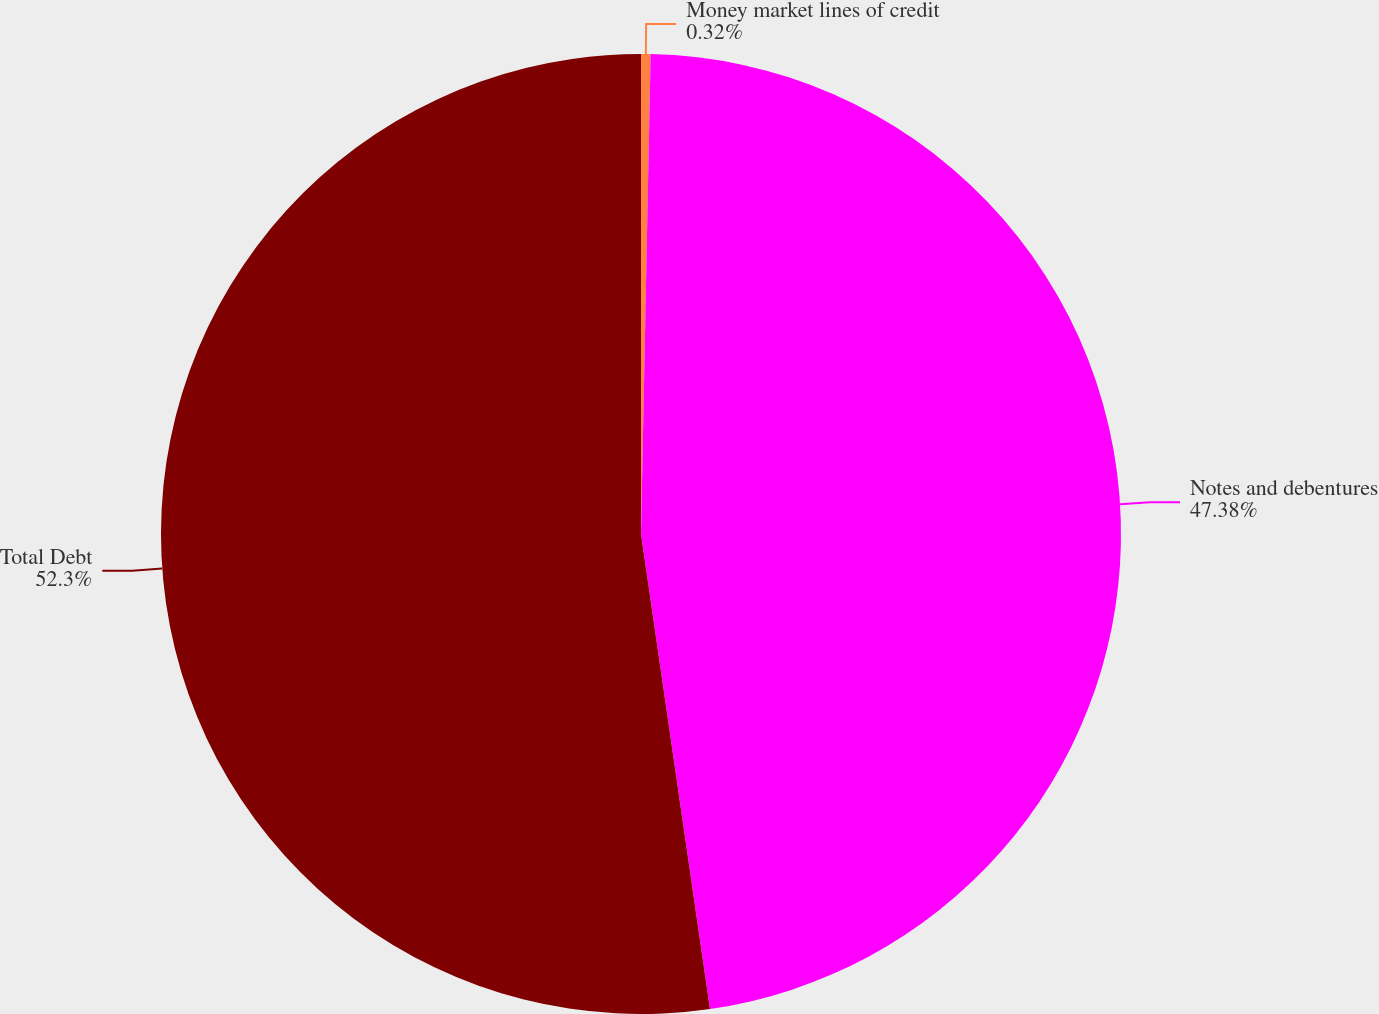<chart> <loc_0><loc_0><loc_500><loc_500><pie_chart><fcel>Money market lines of credit<fcel>Notes and debentures<fcel>Total Debt<nl><fcel>0.32%<fcel>47.38%<fcel>52.29%<nl></chart> 